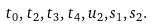<formula> <loc_0><loc_0><loc_500><loc_500>t _ { 0 } , t _ { 2 } , t _ { 3 } , t _ { 4 } , u _ { 2 } , s _ { 1 } , s _ { 2 } .</formula> 